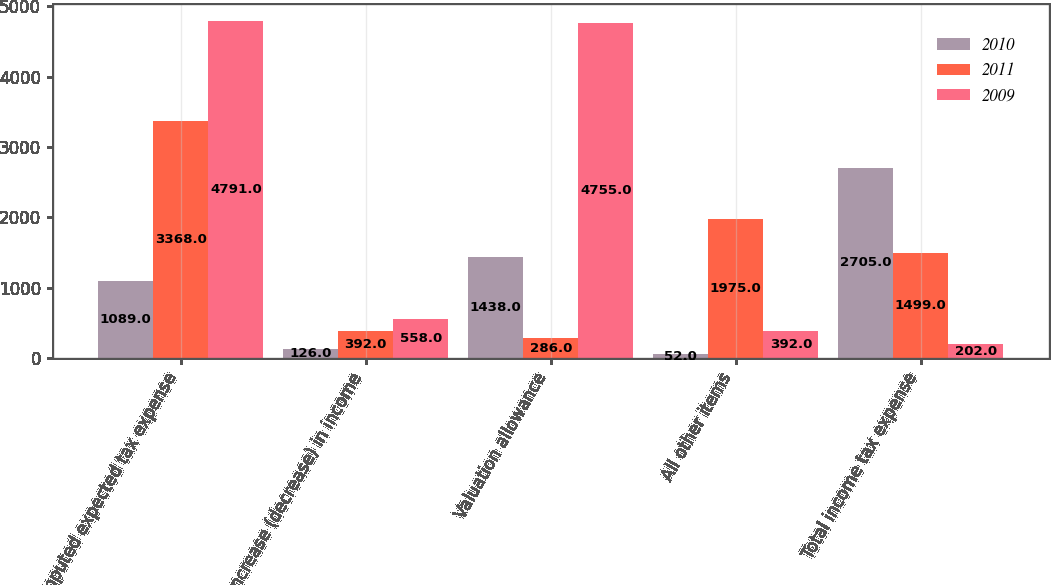Convert chart to OTSL. <chart><loc_0><loc_0><loc_500><loc_500><stacked_bar_chart><ecel><fcel>Computed expected tax expense<fcel>Increase (decrease) in income<fcel>Valuation allowance<fcel>All other items<fcel>Total income tax expense<nl><fcel>2010<fcel>1089<fcel>126<fcel>1438<fcel>52<fcel>2705<nl><fcel>2011<fcel>3368<fcel>392<fcel>286<fcel>1975<fcel>1499<nl><fcel>2009<fcel>4791<fcel>558<fcel>4755<fcel>392<fcel>202<nl></chart> 